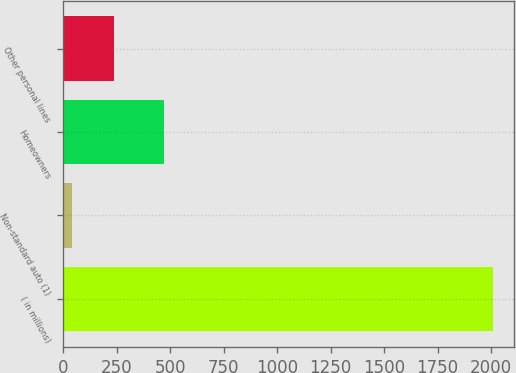<chart> <loc_0><loc_0><loc_500><loc_500><bar_chart><fcel>( in millions)<fcel>Non-standard auto (1)<fcel>Homeowners<fcel>Other personal lines<nl><fcel>2008<fcel>40<fcel>471<fcel>236.8<nl></chart> 